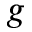<formula> <loc_0><loc_0><loc_500><loc_500>g</formula> 